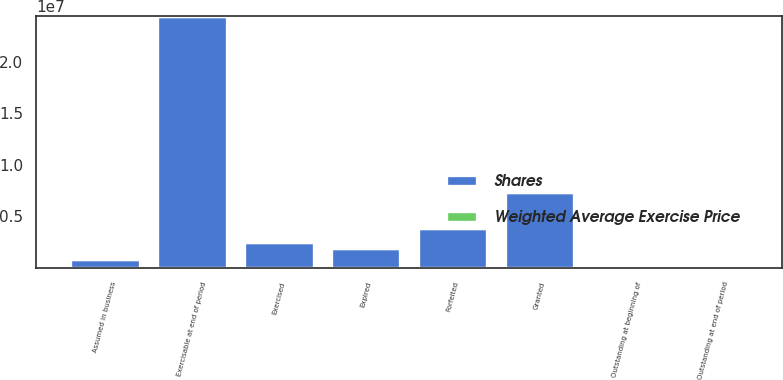Convert chart to OTSL. <chart><loc_0><loc_0><loc_500><loc_500><stacked_bar_chart><ecel><fcel>Outstanding at beginning of<fcel>Assumed in business<fcel>Granted<fcel>Exercised<fcel>Forfeited<fcel>Expired<fcel>Outstanding at end of period<fcel>Exercisable at end of period<nl><fcel>Shares<fcel>40.26<fcel>846953<fcel>7.38726e+06<fcel>2.4669e+06<fcel>3.85995e+06<fcel>1.90342e+06<fcel>40.26<fcel>2.4474e+07<nl><fcel>Weighted Average Exercise Price<fcel>31.51<fcel>1.99<fcel>20.5<fcel>12.4<fcel>41.27<fcel>39.25<fcel>28.38<fcel>32.69<nl></chart> 